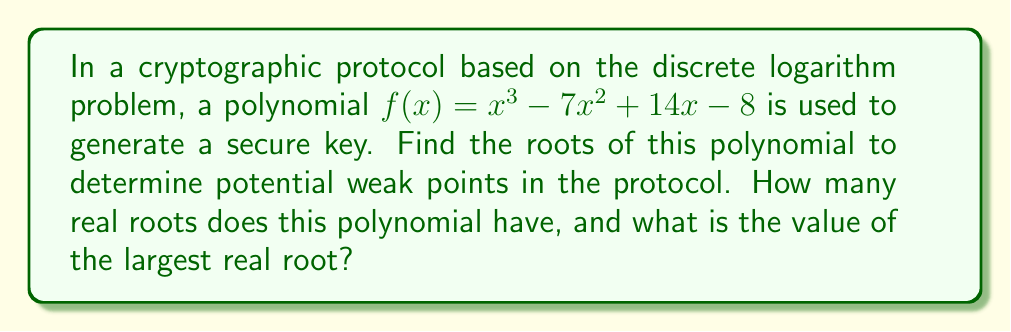Provide a solution to this math problem. To find the roots of the polynomial $f(x) = x^3 - 7x^2 + 14x - 8$, we can use the rational root theorem and synthetic division.

Step 1: Determine potential rational roots using the rational root theorem.
The potential rational roots are the factors of the constant term (8): ±1, ±2, ±4, ±8

Step 2: Use synthetic division to test these potential roots.

Testing x = 1:
$$
\begin{array}{r}
1 \enclose{longdiv}{1 \quad -7 \quad 14 \quad -8} \\
\underline{1 \quad -6 \quad 8} \\
1 \quad -6 \quad 8 \quad 0
\end{array}
$$

We found that 1 is a root of the polynomial.

Step 3: Factor out (x - 1) from the original polynomial.
$f(x) = (x - 1)(x^2 - 6x + 8)$

Step 4: Solve the quadratic equation $x^2 - 6x + 8 = 0$ using the quadratic formula.

$x = \frac{-b \pm \sqrt{b^2 - 4ac}}{2a}$

$x = \frac{6 \pm \sqrt{36 - 32}}{2} = \frac{6 \pm \sqrt{4}}{2} = \frac{6 \pm 2}{2}$

$x = 4$ or $x = 2$

Therefore, the three roots of the polynomial are 1, 2, and 4.

Step 5: Determine the number of real roots and the largest real root.
All three roots (1, 2, and 4) are real numbers.
The largest real root is 4.
Answer: 3 real roots; largest root is 4 